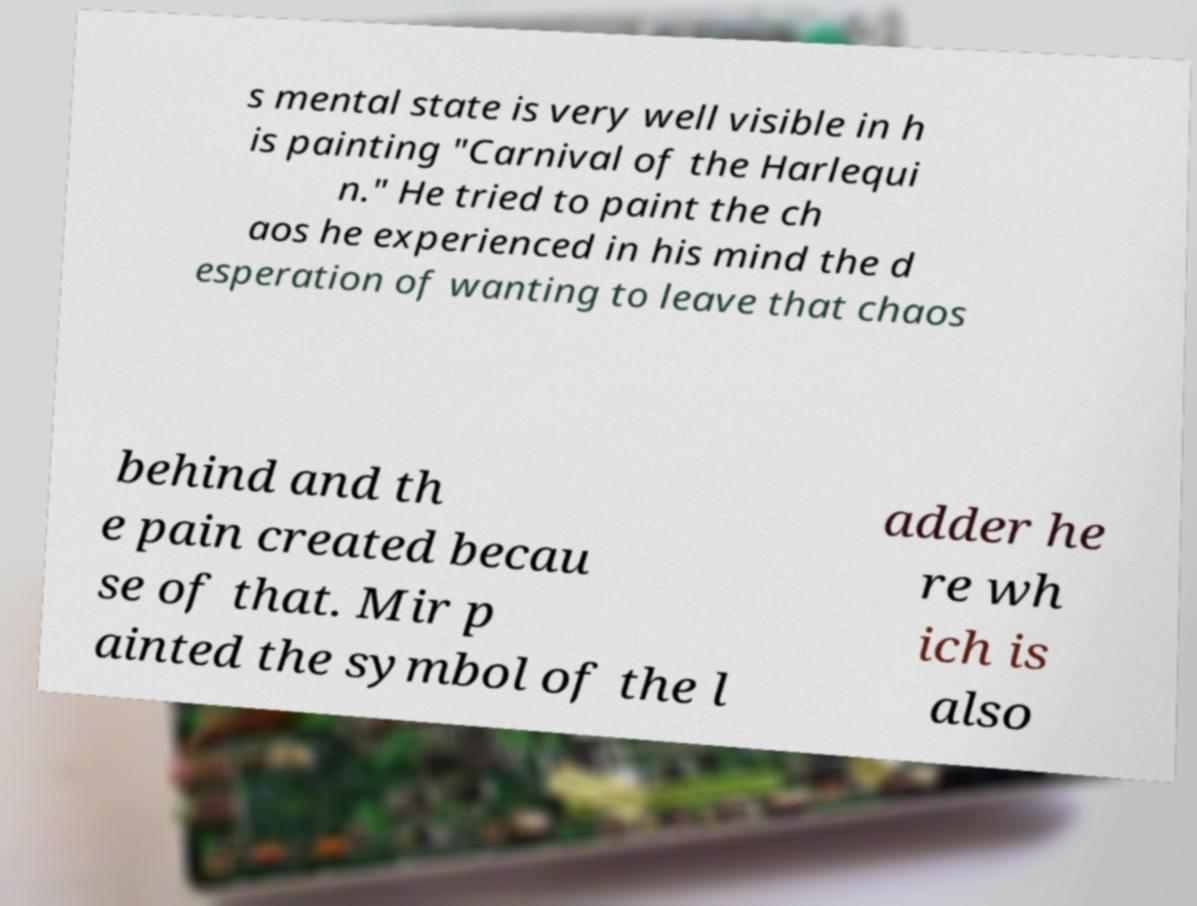Please identify and transcribe the text found in this image. s mental state is very well visible in h is painting "Carnival of the Harlequi n." He tried to paint the ch aos he experienced in his mind the d esperation of wanting to leave that chaos behind and th e pain created becau se of that. Mir p ainted the symbol of the l adder he re wh ich is also 